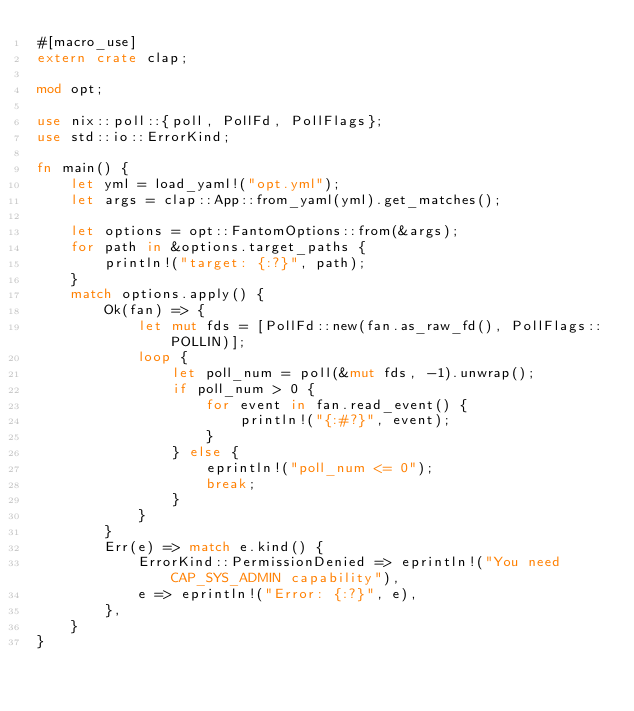Convert code to text. <code><loc_0><loc_0><loc_500><loc_500><_Rust_>#[macro_use]
extern crate clap;

mod opt;

use nix::poll::{poll, PollFd, PollFlags};
use std::io::ErrorKind;

fn main() {
    let yml = load_yaml!("opt.yml");
    let args = clap::App::from_yaml(yml).get_matches();

    let options = opt::FantomOptions::from(&args);
    for path in &options.target_paths {
        println!("target: {:?}", path);
    }
    match options.apply() {
        Ok(fan) => {
            let mut fds = [PollFd::new(fan.as_raw_fd(), PollFlags::POLLIN)];
            loop {
                let poll_num = poll(&mut fds, -1).unwrap();
                if poll_num > 0 {
                    for event in fan.read_event() {
                        println!("{:#?}", event);
                    }
                } else {
                    eprintln!("poll_num <= 0");
                    break;
                }
            }
        }
        Err(e) => match e.kind() {
            ErrorKind::PermissionDenied => eprintln!("You need CAP_SYS_ADMIN capability"),
            e => eprintln!("Error: {:?}", e),
        },
    }
}
</code> 